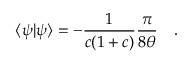<formula> <loc_0><loc_0><loc_500><loc_500>\langle \psi | \psi \rangle = - \frac { 1 } { c ( 1 + c ) } \frac { \pi } { 8 \theta } \quad .</formula> 